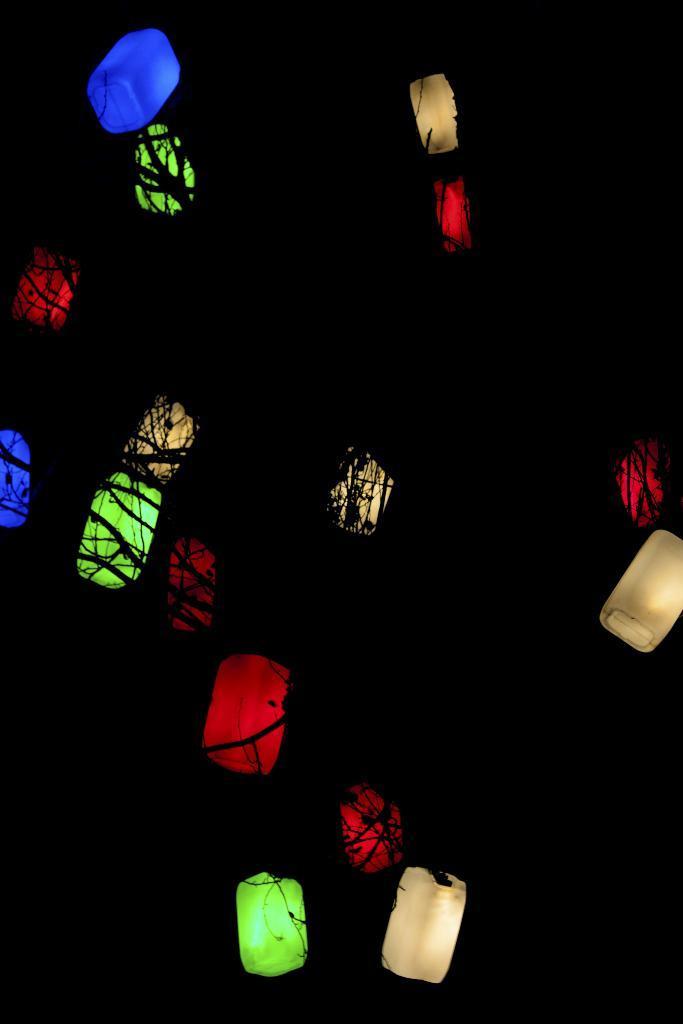How would you summarize this image in a sentence or two? In this image there are lights. 